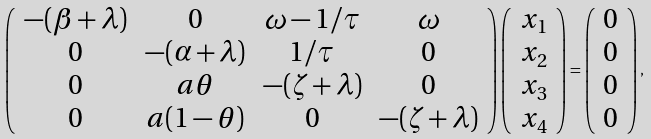<formula> <loc_0><loc_0><loc_500><loc_500>\left ( \begin{array} { c c c c } - ( \beta + \lambda ) & 0 & \omega - 1 / \tau & \omega \\ 0 & - ( \alpha + \lambda ) & 1 / \tau & 0 \\ 0 & a \theta & - ( \zeta + \lambda ) & 0 \\ 0 & a ( 1 - \theta ) & 0 & - ( \zeta + \lambda ) \end{array} \right ) \left ( \begin{array} { c } x _ { 1 } \\ x _ { 2 } \\ x _ { 3 } \\ x _ { 4 } \end{array} \right ) = \left ( \begin{array} { c } 0 \\ 0 \\ 0 \\ 0 \end{array} \right ) ,</formula> 